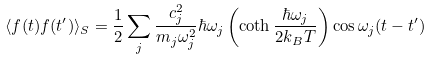<formula> <loc_0><loc_0><loc_500><loc_500>\langle f ( t ) f ( t ^ { \prime } ) \rangle _ { S } = \frac { 1 } { 2 } \sum _ { j } \frac { c _ { j } ^ { 2 } } { m _ { j } \omega _ { j } ^ { 2 } } \hbar { \omega } _ { j } \left ( \coth \frac { \hbar { \omega } _ { j } } { 2 k _ { B } T } \right ) \cos \omega _ { j } ( t - t ^ { \prime } )</formula> 